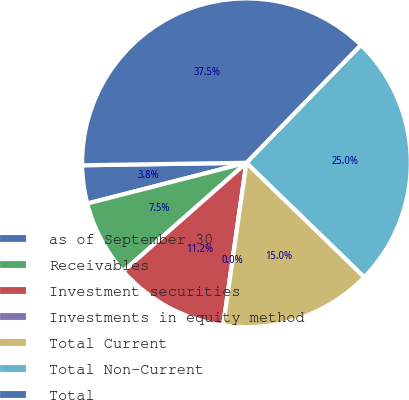Convert chart. <chart><loc_0><loc_0><loc_500><loc_500><pie_chart><fcel>as of September 30<fcel>Receivables<fcel>Investment securities<fcel>Investments in equity method<fcel>Total Current<fcel>Total Non-Current<fcel>Total<nl><fcel>3.75%<fcel>7.5%<fcel>11.25%<fcel>0.0%<fcel>15.0%<fcel>24.99%<fcel>37.51%<nl></chart> 